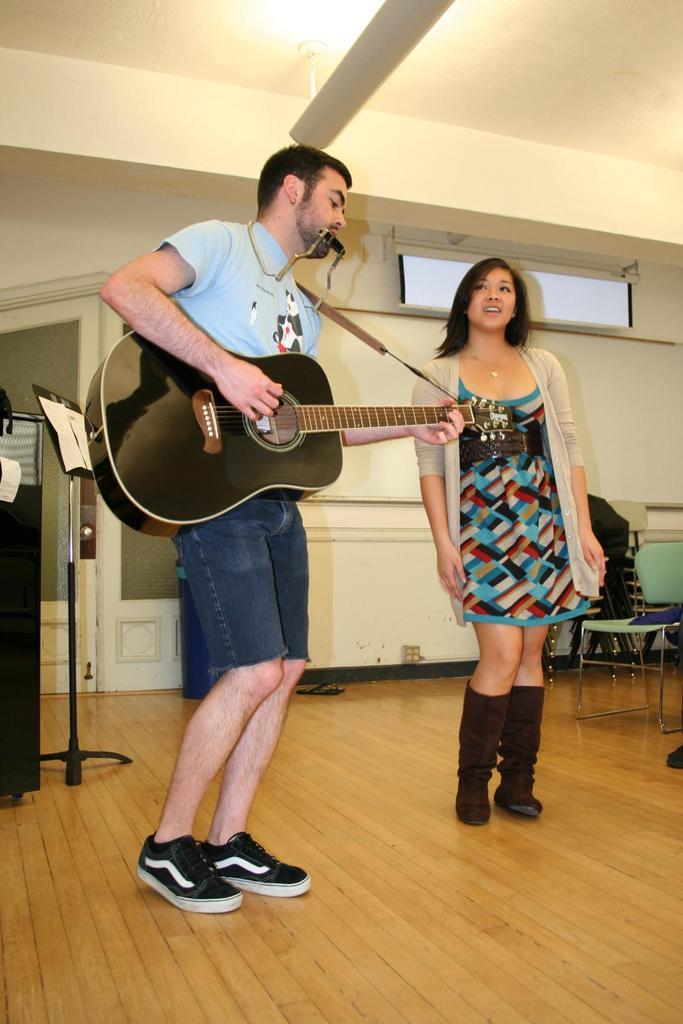What is the color of the wall in the image? The wall in the image is white. How many people are present in the image? There are two people in the image. Can you describe one of the individuals in the image? One of the people is a man. What is the man holding in the image? The man is holding a guitar. What type of drum can be seen on the top of the wall in the image? There is no drum visible on the wall in the image, as it is a white color wall with no additional objects mentioned. 